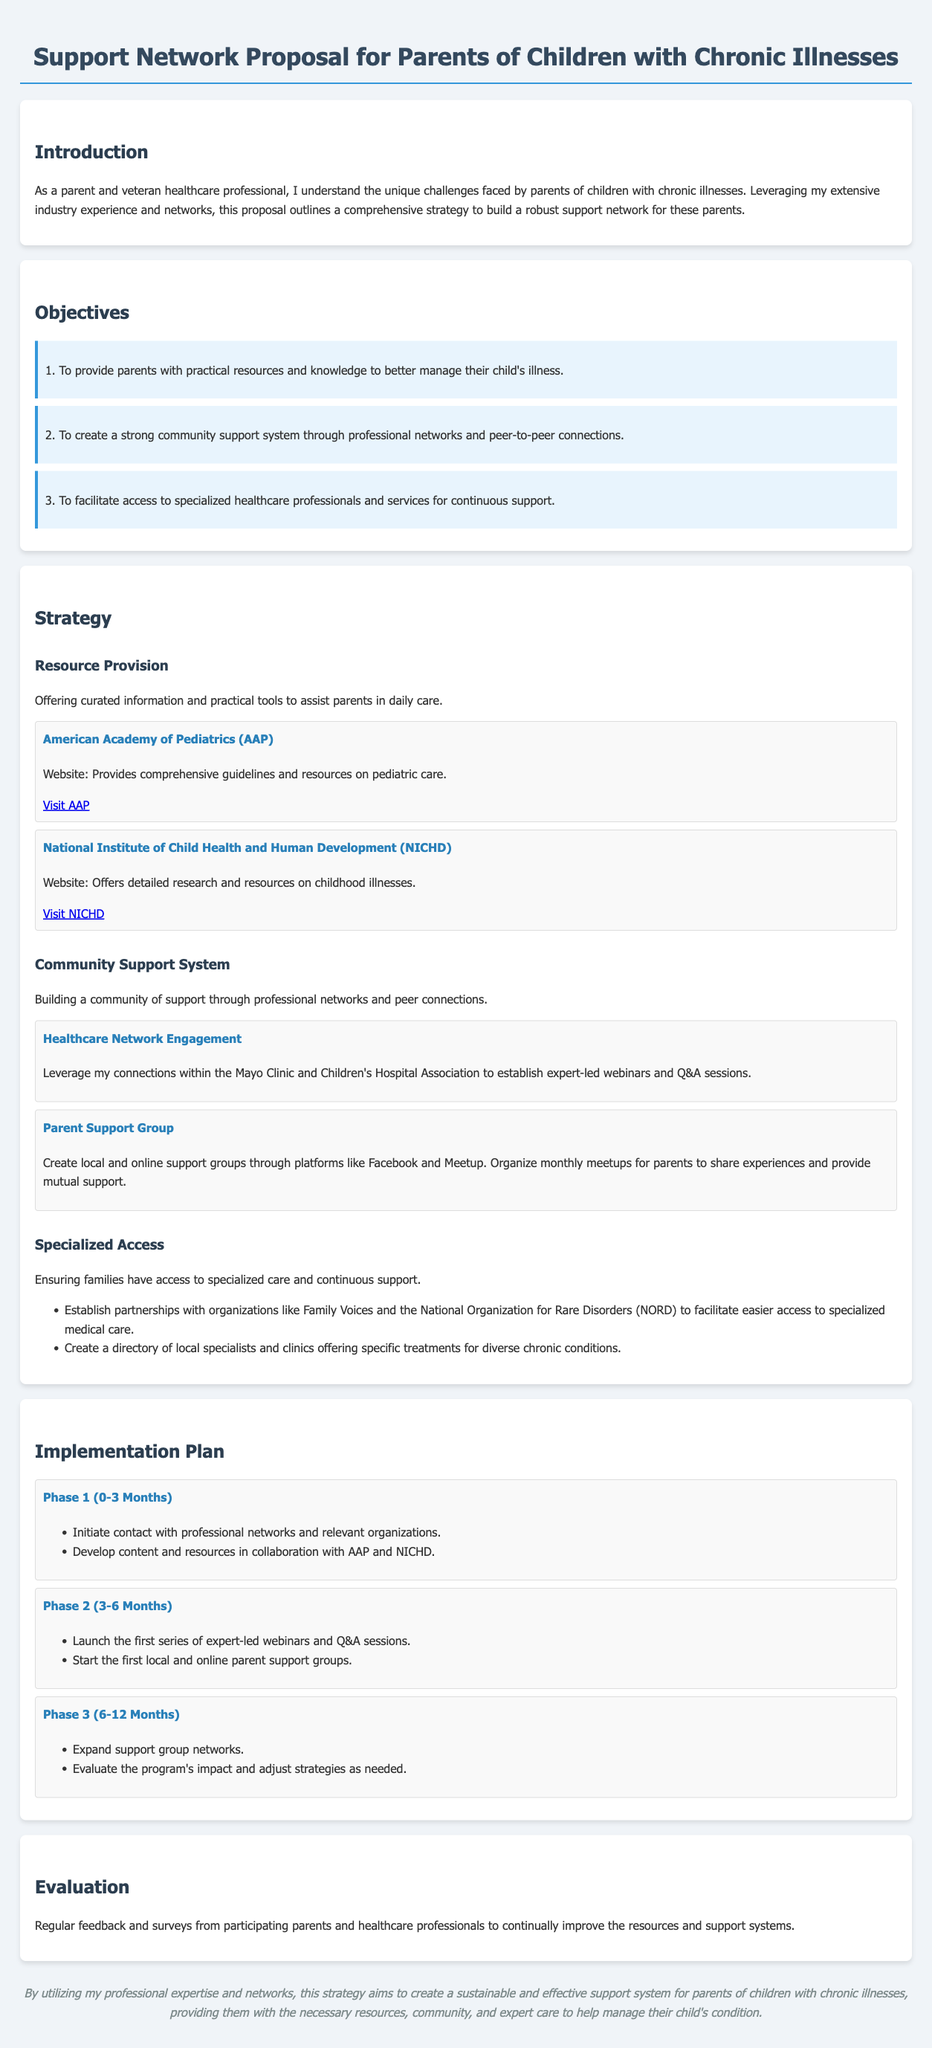what are the main objectives of the proposal? The main objectives are outlined in the Objectives section, which includes three specific goals.
Answer: To provide practical resources, create a community support system, facilitate access to healthcare professionals what organization provides guidelines on pediatric care? The organization mentioned in the Resources section known for its guidelines is the American Academy of Pediatrics.
Answer: American Academy of Pediatrics how long is Phase 1 of the implementation plan? Phase 1 is detailed to cover the first 3 months of the implementation plan.
Answer: 0-3 Months what type of support groups are mentioned in the proposal? The proposal discusses creating both local and online support groups for parents.
Answer: Local and online support groups which phase focuses on launching webinars? Phase 2 of the implementation plan is dedicated to launching the expert-led webinars and Q&A sessions.
Answer: Phase 2 how will the proposal evaluate its success? The proposal plans to use regular feedback and surveys from participating parents and healthcare professionals for evaluation.
Answer: Feedback and surveys what is the ultimate goal of the proposal? The ultimate goal is to create a sustainable support system for parents of children with chronic illnesses.
Answer: Sustainable support system 